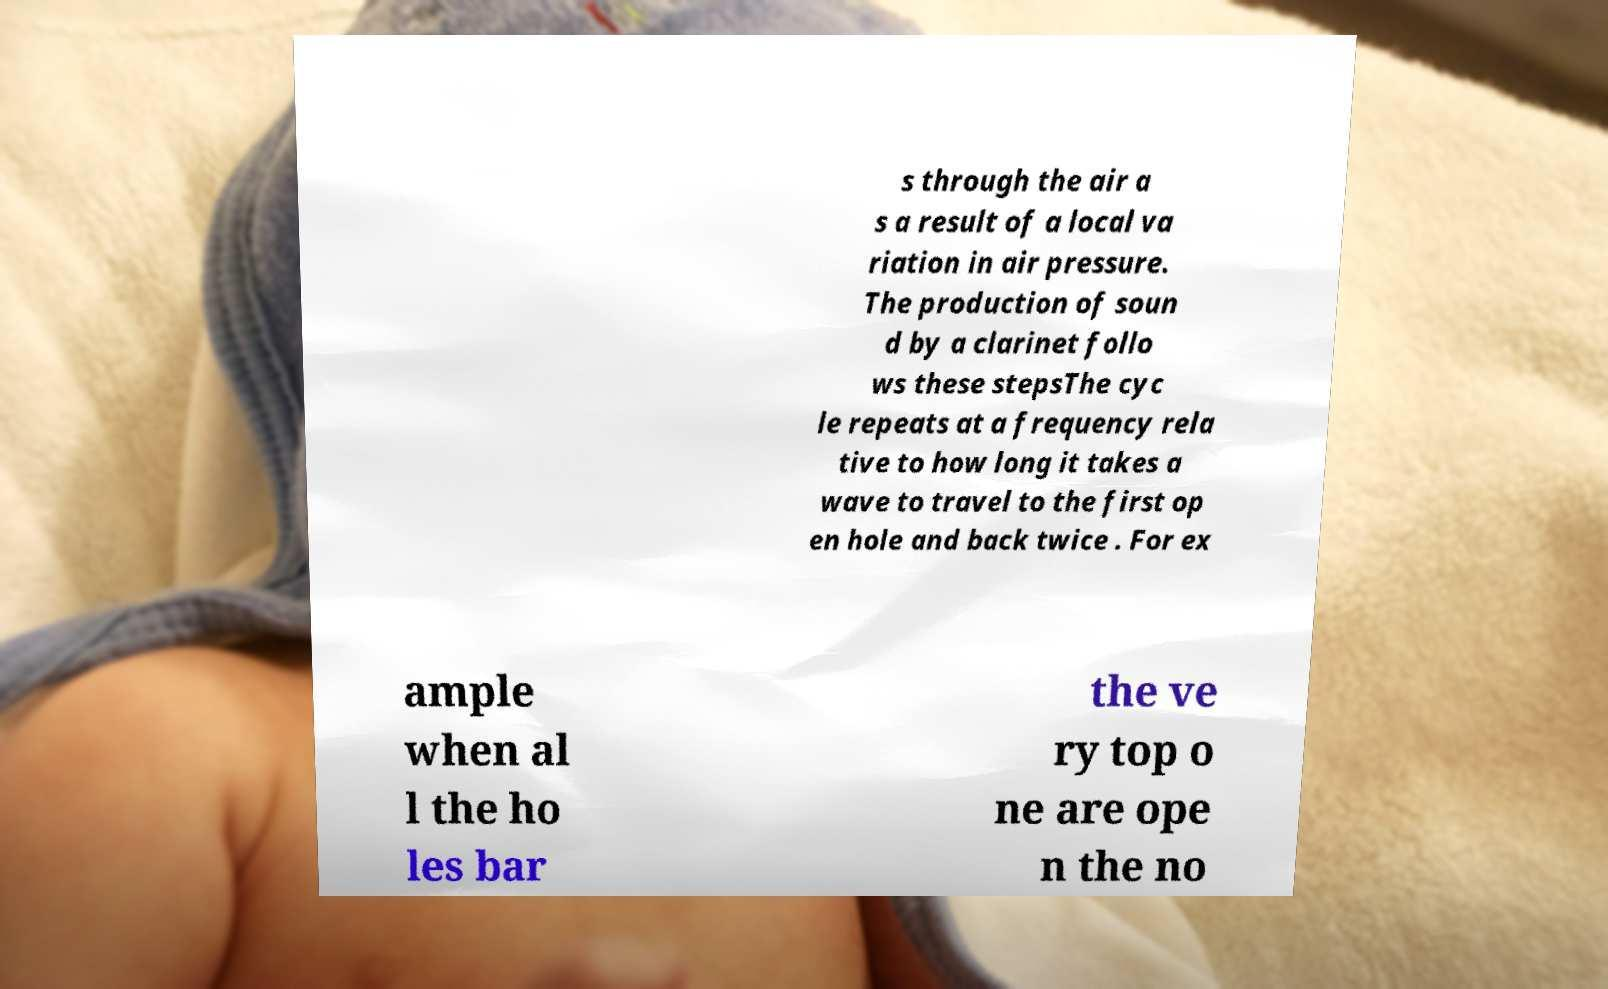Could you extract and type out the text from this image? s through the air a s a result of a local va riation in air pressure. The production of soun d by a clarinet follo ws these stepsThe cyc le repeats at a frequency rela tive to how long it takes a wave to travel to the first op en hole and back twice . For ex ample when al l the ho les bar the ve ry top o ne are ope n the no 